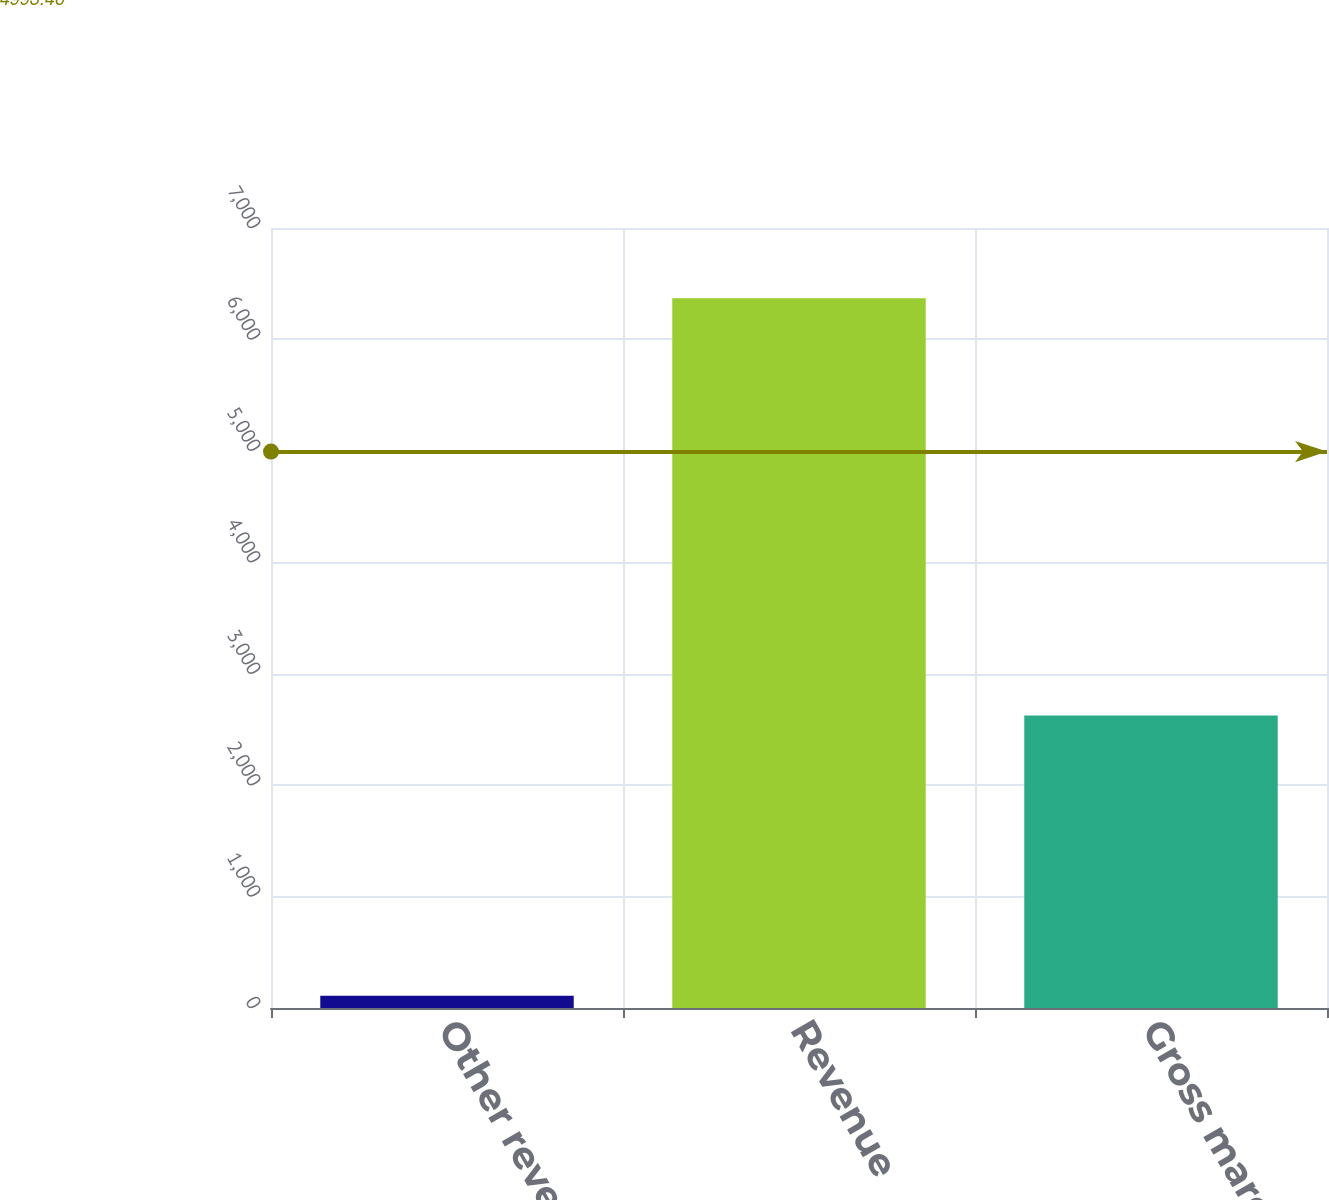Convert chart to OTSL. <chart><loc_0><loc_0><loc_500><loc_500><bar_chart><fcel>Other revenue<fcel>Revenue<fcel>Gross margin<nl><fcel>109<fcel>6369<fcel>2626<nl></chart> 